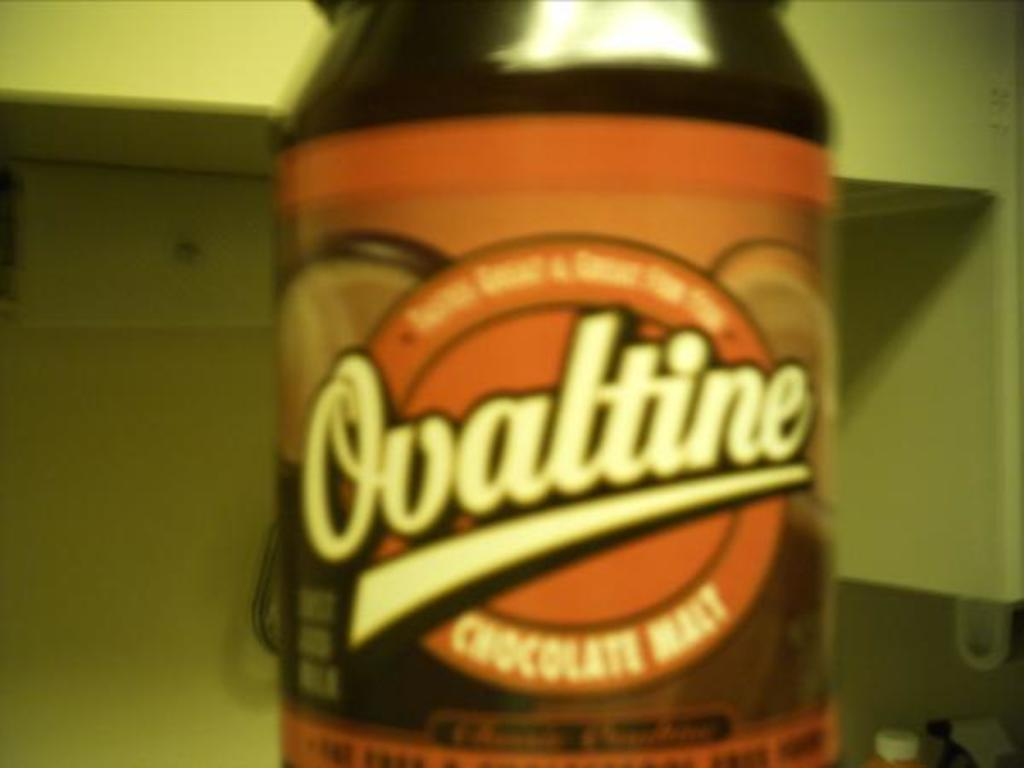<image>
Give a short and clear explanation of the subsequent image. a close up of a bottle of Ovaltine Chocolate drink 